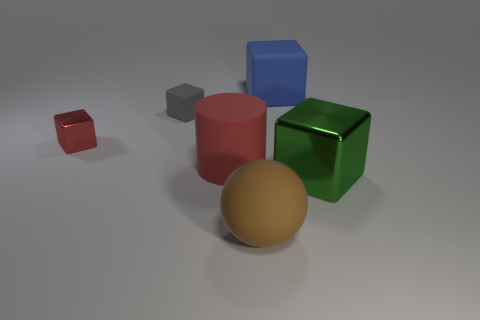What is the material of the big cylinder that is the same color as the small shiny thing?
Keep it short and to the point. Rubber. What is the shape of the thing that is both behind the red cube and to the right of the tiny gray matte thing?
Your answer should be compact. Cube. What number of large yellow balls are made of the same material as the large blue thing?
Keep it short and to the point. 0. Are there fewer big green metal things that are behind the small gray thing than gray rubber things?
Offer a terse response. Yes. There is a cube that is right of the blue thing; is there a large shiny object behind it?
Provide a succinct answer. No. Is there anything else that has the same shape as the large red rubber object?
Keep it short and to the point. No. Is the blue cube the same size as the red block?
Offer a very short reply. No. The large object that is in front of the cube that is in front of the red object that is behind the red matte thing is made of what material?
Keep it short and to the point. Rubber. Are there the same number of brown things that are behind the red metallic thing and metallic objects?
Give a very brief answer. No. Is there any other thing that is the same size as the green shiny thing?
Ensure brevity in your answer.  Yes. 